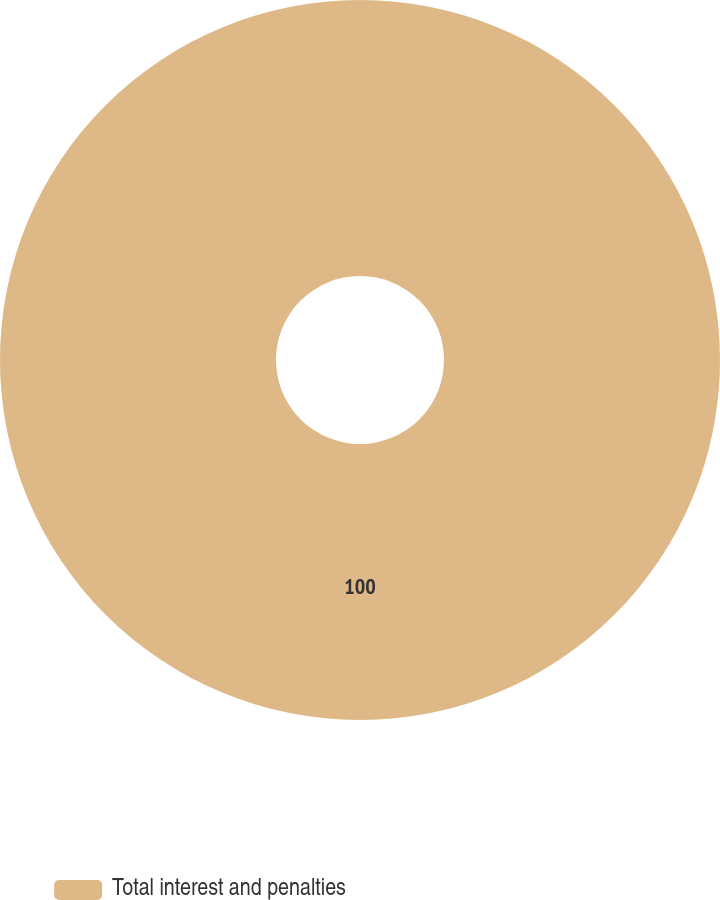<chart> <loc_0><loc_0><loc_500><loc_500><pie_chart><fcel>Total interest and penalties<nl><fcel>100.0%<nl></chart> 